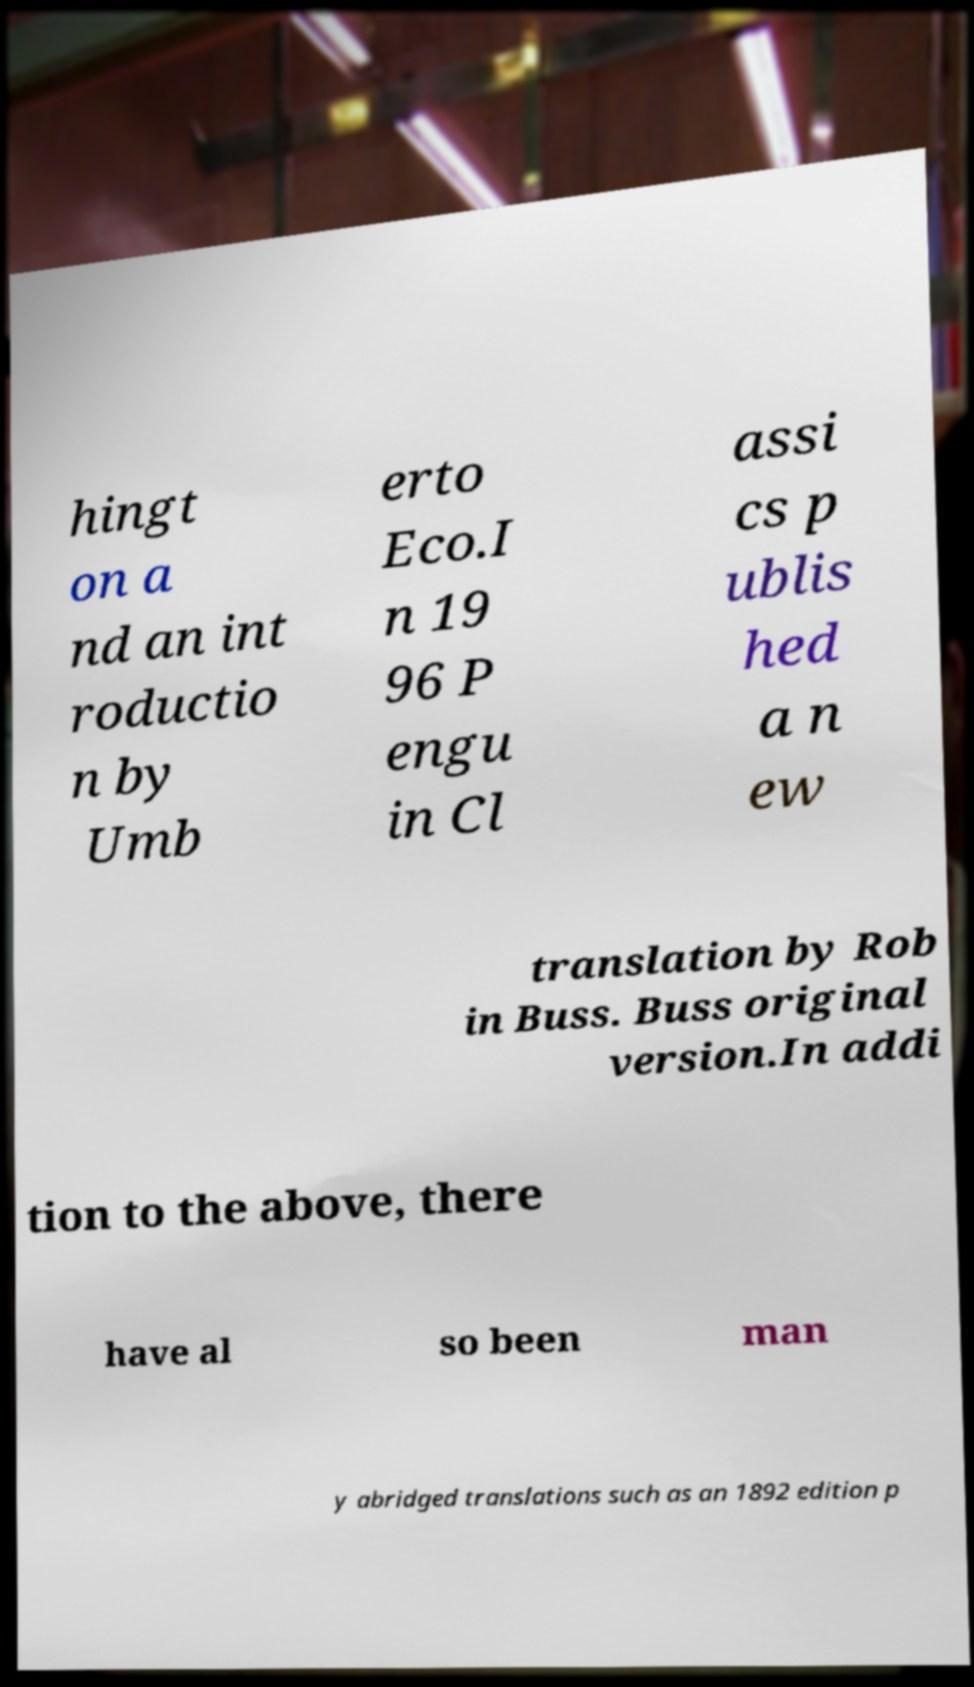Can you read and provide the text displayed in the image?This photo seems to have some interesting text. Can you extract and type it out for me? hingt on a nd an int roductio n by Umb erto Eco.I n 19 96 P engu in Cl assi cs p ublis hed a n ew translation by Rob in Buss. Buss original version.In addi tion to the above, there have al so been man y abridged translations such as an 1892 edition p 